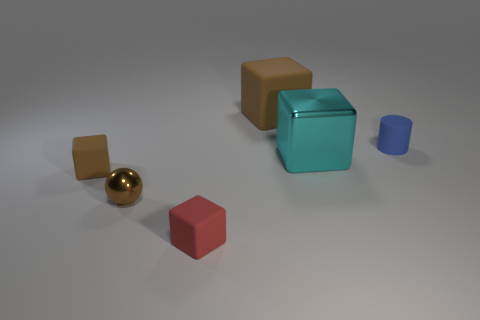Subtract all red cubes. How many cubes are left? 3 Subtract all red matte blocks. How many blocks are left? 3 Subtract all yellow blocks. Subtract all blue cylinders. How many blocks are left? 4 Add 4 brown shiny spheres. How many objects exist? 10 Subtract 0 blue blocks. How many objects are left? 6 Subtract all balls. How many objects are left? 5 Subtract all cyan matte things. Subtract all small brown balls. How many objects are left? 5 Add 6 tiny brown matte cubes. How many tiny brown matte cubes are left? 7 Add 1 small blue cylinders. How many small blue cylinders exist? 2 